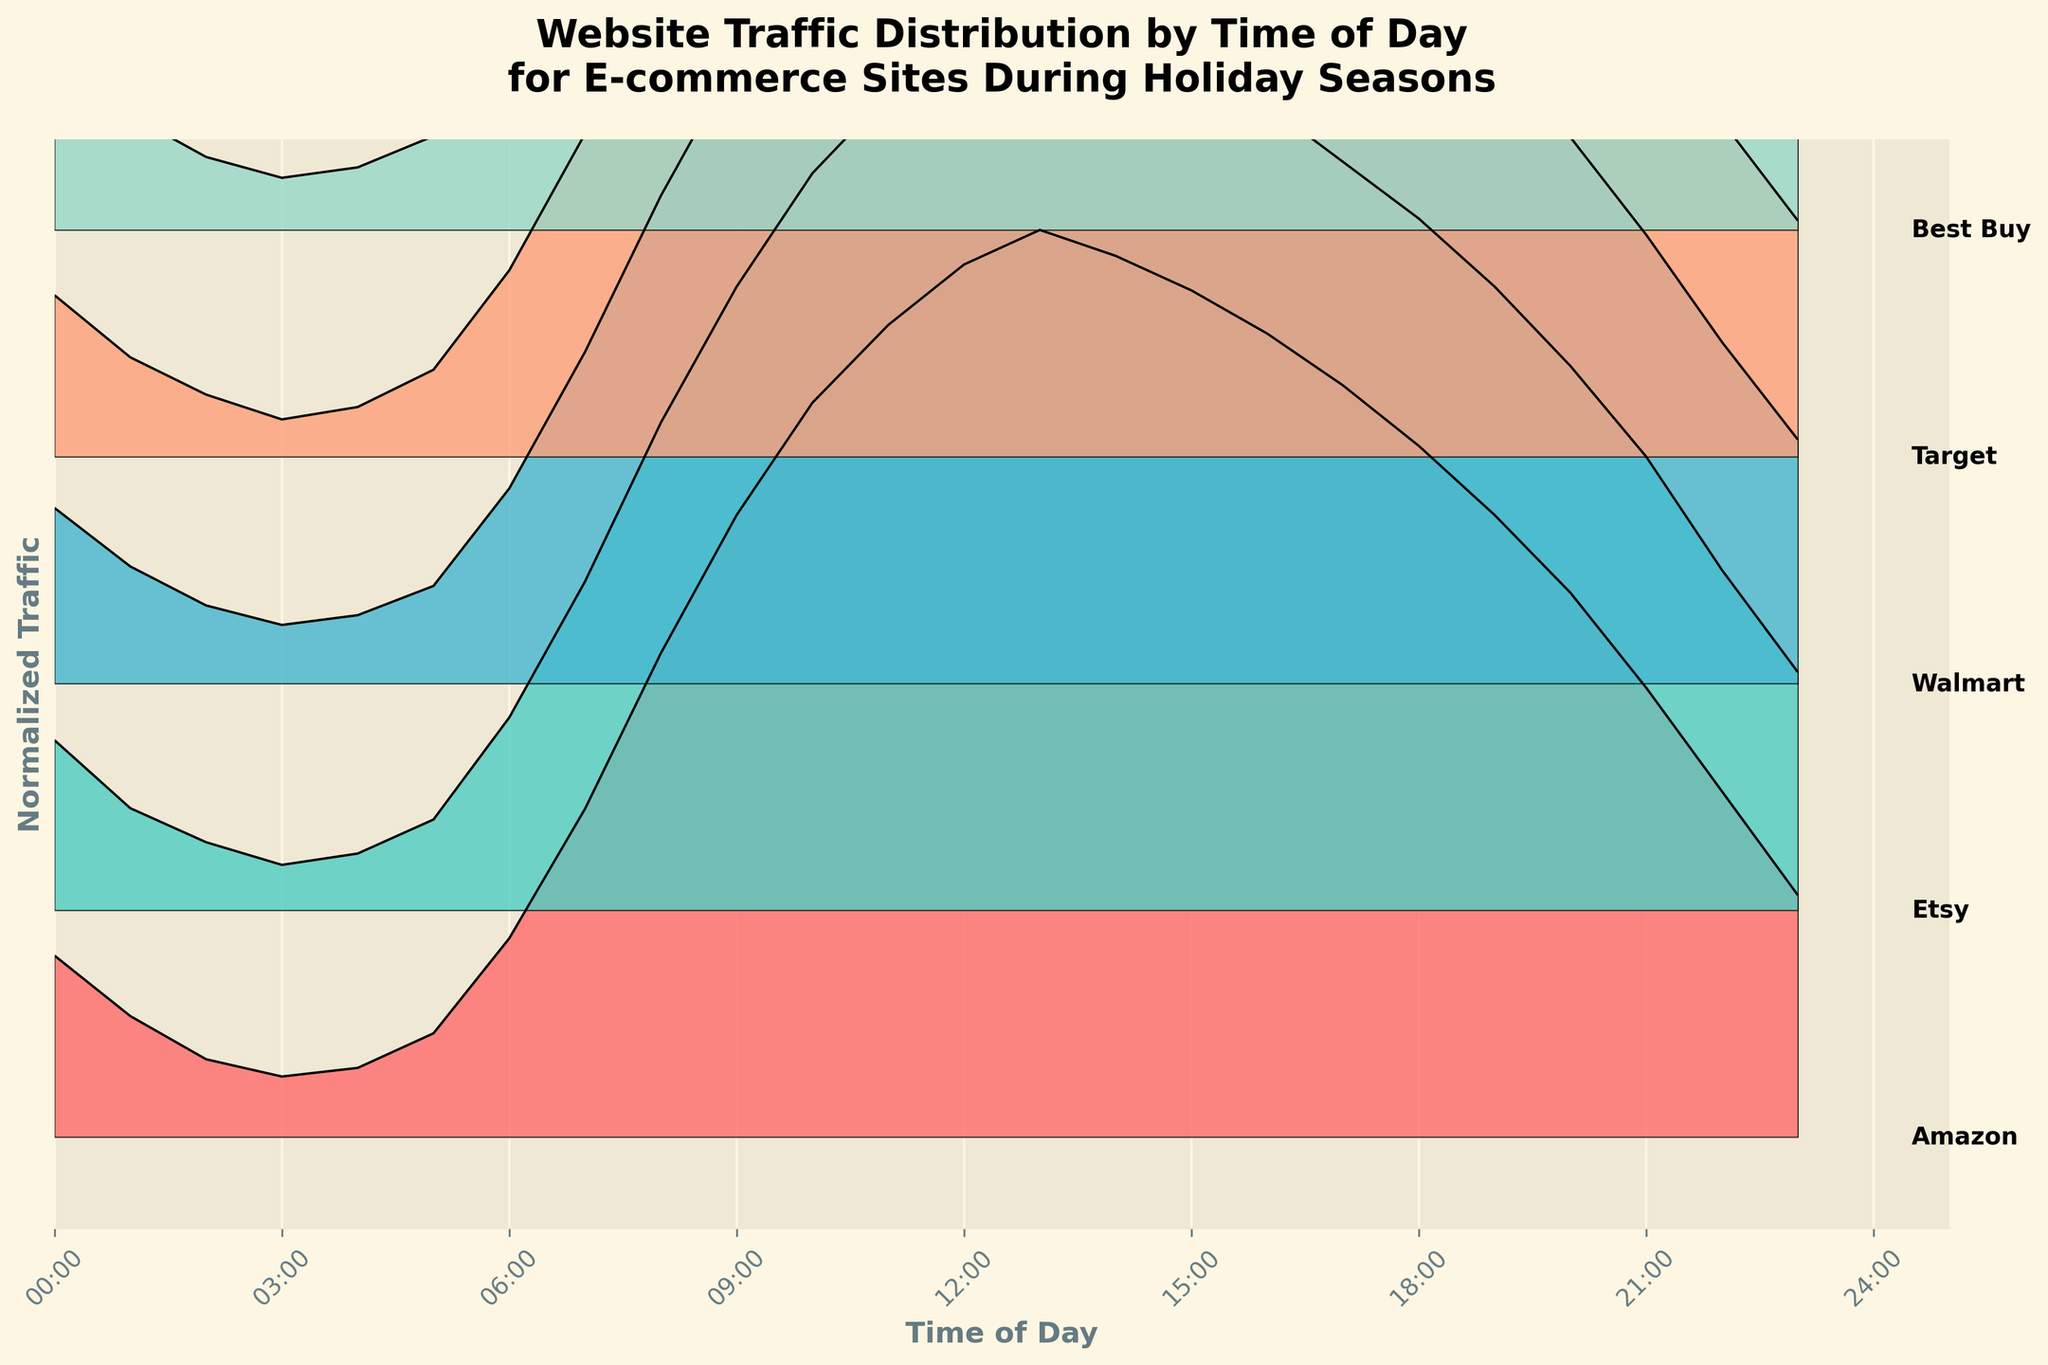What is the title of the ridgeline plot? The title of the plot is located at the top and summarizes the key information presented in the visual.
Answer: "Website Traffic Distribution by Time of Day for E-commerce Sites During Holiday Seasons" At what time of day does Amazon reach its peak normalized traffic? Locate the Amazon ridgeline in the plot, identify the highest point and see its corresponding time on the x-axis.
Answer: 13:00 Which e-commerce site shows the least traffic at 3 AM? Check all the ridgelines at the 3 AM mark and identify which one has the lowest value.
Answer: Target How does Etsy's traffic at 9 AM compare to its traffic at 9 PM? Locate the values for Etsy at 9 AM and 9 PM on the plot, then compare which value is higher.
Answer: 9 AM > 9 PM What are the three e-commerce sites with the highest traffic peak, and at what time do they occur? Identify the peaks of all ridgelines, then select the top three and note the time they occur.
Answer: Amazon (13:00), Etsy (13:00), Walmart (13:00) What is the range (difference between the highest and lowest traffic) for Walmart from 0:00 to 23:00? Find the highest and lowest points on Walmart's ridgeline, then calculate the difference between these values.
Answer: 9.3 (13:00) - 0.6 (3:00) = 8.7 What color is used to represent Best Buy, and what could this color signify? Identify the color corresponding to Best Buy on the plot, describe it, and infer any possible reason for its choice (e.g., brand colors or visual contrast).
Answer: Light green, possibly for visual ease Which site experiences a gradual increase in traffic and maintains a high level of traffic from midday to the evening? Identify ridgelines with a gradual increase pattern and sustained high traffic levels from 12:00 PM to 6:00 PM.
Answer: Amazon What time ranges do all sites show a decrease in traffic? Identify the sections of each ridgeline where traffic decreases and find overlapping time intervals.
Answer: 15:00 - 23:00 How does the visualization handle overlapping ridgelines to effectively display the data? Examine the visual arrangement and techniques used in the plot to manage overlapping data.
Answer: Uses vertical spacing and color separation 